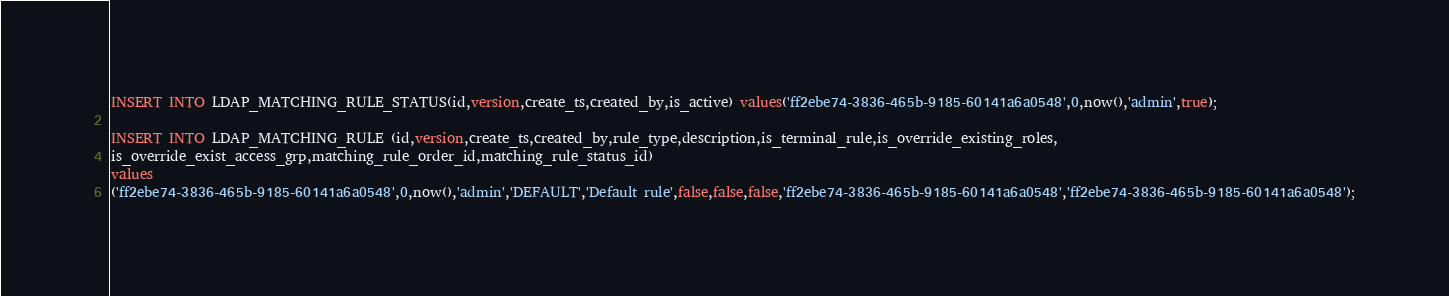<code> <loc_0><loc_0><loc_500><loc_500><_SQL_>INSERT INTO LDAP_MATCHING_RULE_STATUS(id,version,create_ts,created_by,is_active) values('ff2ebe74-3836-465b-9185-60141a6a0548',0,now(),'admin',true);

INSERT INTO LDAP_MATCHING_RULE (id,version,create_ts,created_by,rule_type,description,is_terminal_rule,is_override_existing_roles,
is_override_exist_access_grp,matching_rule_order_id,matching_rule_status_id)
values
('ff2ebe74-3836-465b-9185-60141a6a0548',0,now(),'admin','DEFAULT','Default rule',false,false,false,'ff2ebe74-3836-465b-9185-60141a6a0548','ff2ebe74-3836-465b-9185-60141a6a0548');
</code> 